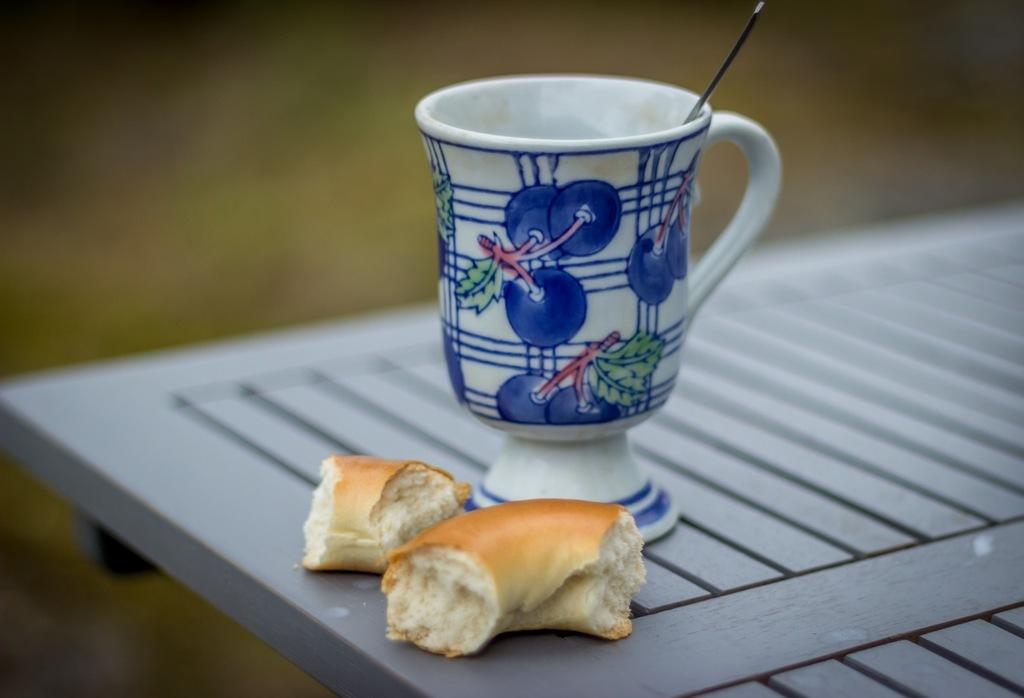What is the main piece of furniture in the image? There is a table in the image. What type of food is on the table? There are bun slices on the table. What is the cup on the table used for? The cup on the table has a spoon in it, which suggests it might be used for drinking or eating. Can you describe the background of the image? The background of the image is blurred. What type of wool is being used to create the stocking in the image? There is no wool or stocking present in the image. What color is the paint on the wall in the image? There is no paint or wall visible in the image. 